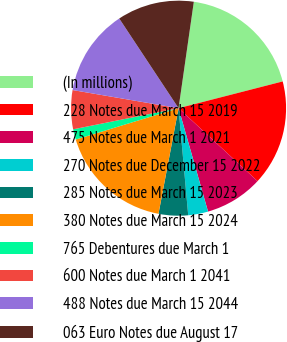Convert chart. <chart><loc_0><loc_0><loc_500><loc_500><pie_chart><fcel>(In millions)<fcel>228 Notes due March 15 2019<fcel>475 Notes due March 1 2021<fcel>270 Notes due December 15 2022<fcel>285 Notes due March 15 2023<fcel>380 Notes due March 15 2024<fcel>765 Debentures due March 1<fcel>600 Notes due March 1 2041<fcel>488 Notes due March 15 2044<fcel>063 Euro Notes due August 17<nl><fcel>18.73%<fcel>15.87%<fcel>8.71%<fcel>2.99%<fcel>4.42%<fcel>17.3%<fcel>1.56%<fcel>5.85%<fcel>13.0%<fcel>11.57%<nl></chart> 